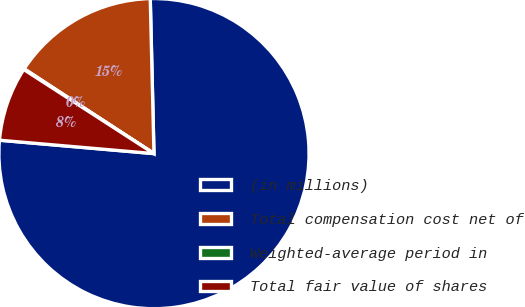<chart> <loc_0><loc_0><loc_500><loc_500><pie_chart><fcel>(in millions)<fcel>Total compensation cost net of<fcel>Weighted-average period in<fcel>Total fair value of shares<nl><fcel>76.76%<fcel>15.41%<fcel>0.08%<fcel>7.75%<nl></chart> 